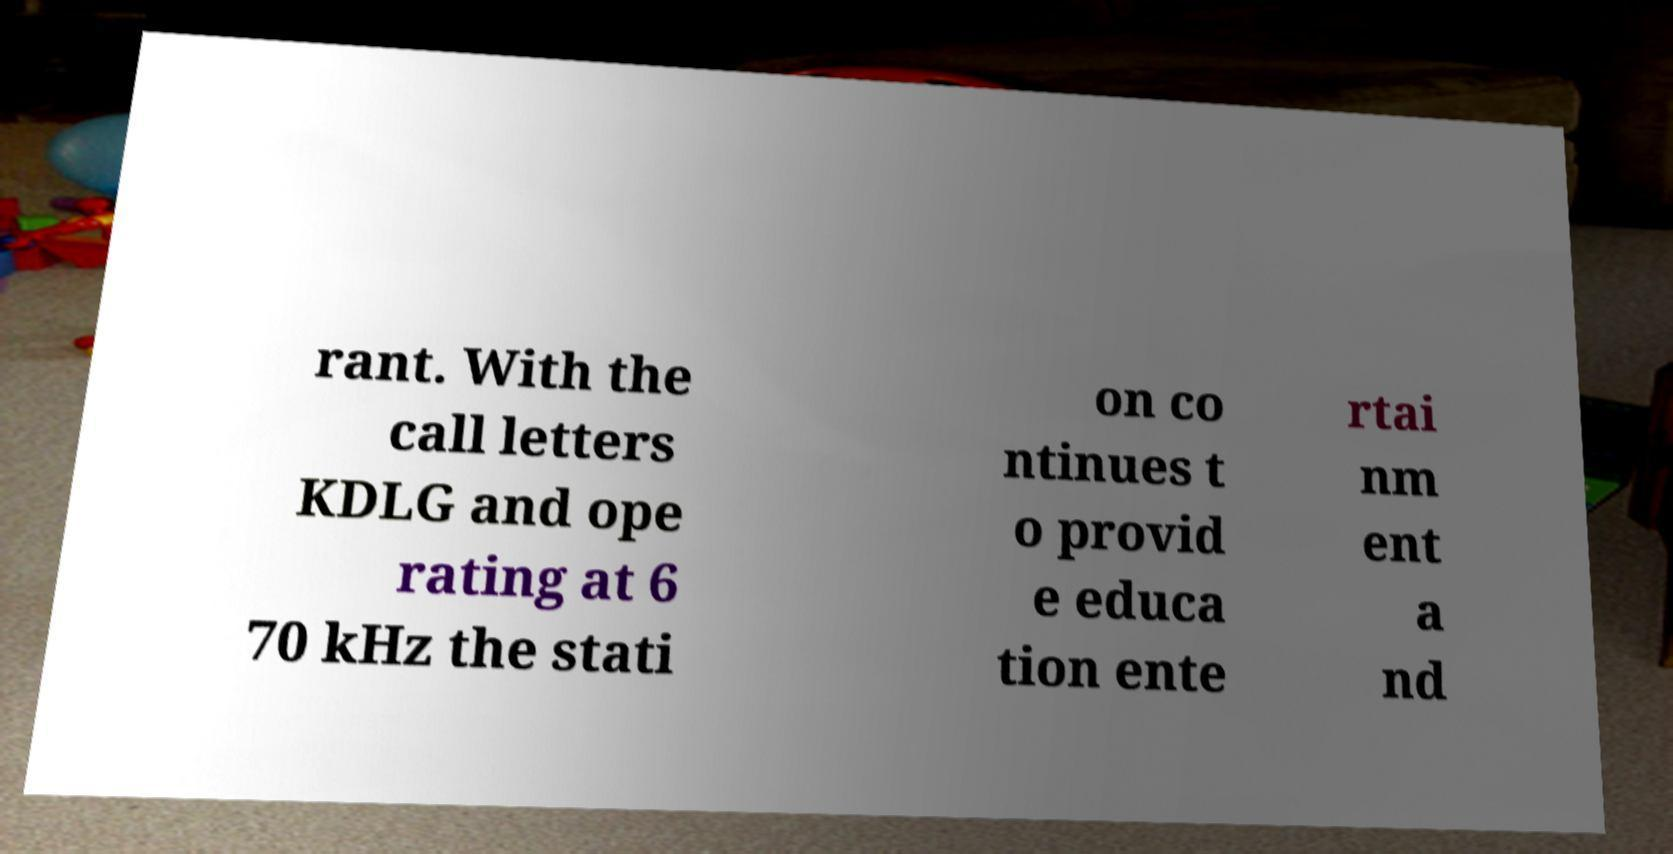Could you extract and type out the text from this image? rant. With the call letters KDLG and ope rating at 6 70 kHz the stati on co ntinues t o provid e educa tion ente rtai nm ent a nd 